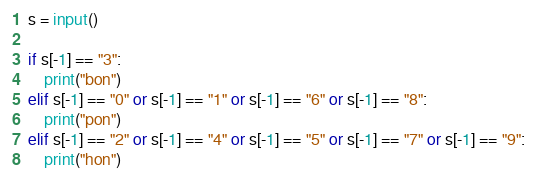<code> <loc_0><loc_0><loc_500><loc_500><_Python_>s = input()

if s[-1] == "3":
    print("bon")
elif s[-1] == "0" or s[-1] == "1" or s[-1] == "6" or s[-1] == "8":
    print("pon")
elif s[-1] == "2" or s[-1] == "4" or s[-1] == "5" or s[-1] == "7" or s[-1] == "9":
    print("hon")</code> 